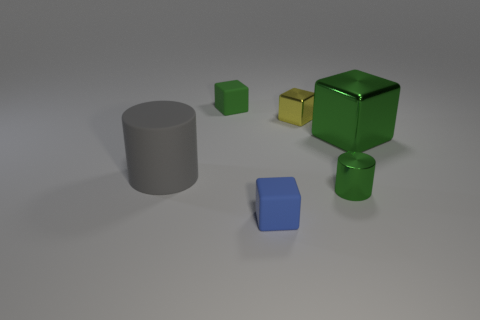Subtract all cyan cylinders. How many green blocks are left? 2 Subtract all blue blocks. How many blocks are left? 3 Add 1 small green rubber cubes. How many objects exist? 7 Subtract all blue cubes. How many cubes are left? 3 Subtract all cyan cubes. Subtract all gray cylinders. How many cubes are left? 4 Subtract all cylinders. How many objects are left? 4 Subtract all large brown shiny cylinders. Subtract all tiny metallic cubes. How many objects are left? 5 Add 4 green metallic cubes. How many green metallic cubes are left? 5 Add 6 tiny shiny things. How many tiny shiny things exist? 8 Subtract 0 cyan cylinders. How many objects are left? 6 